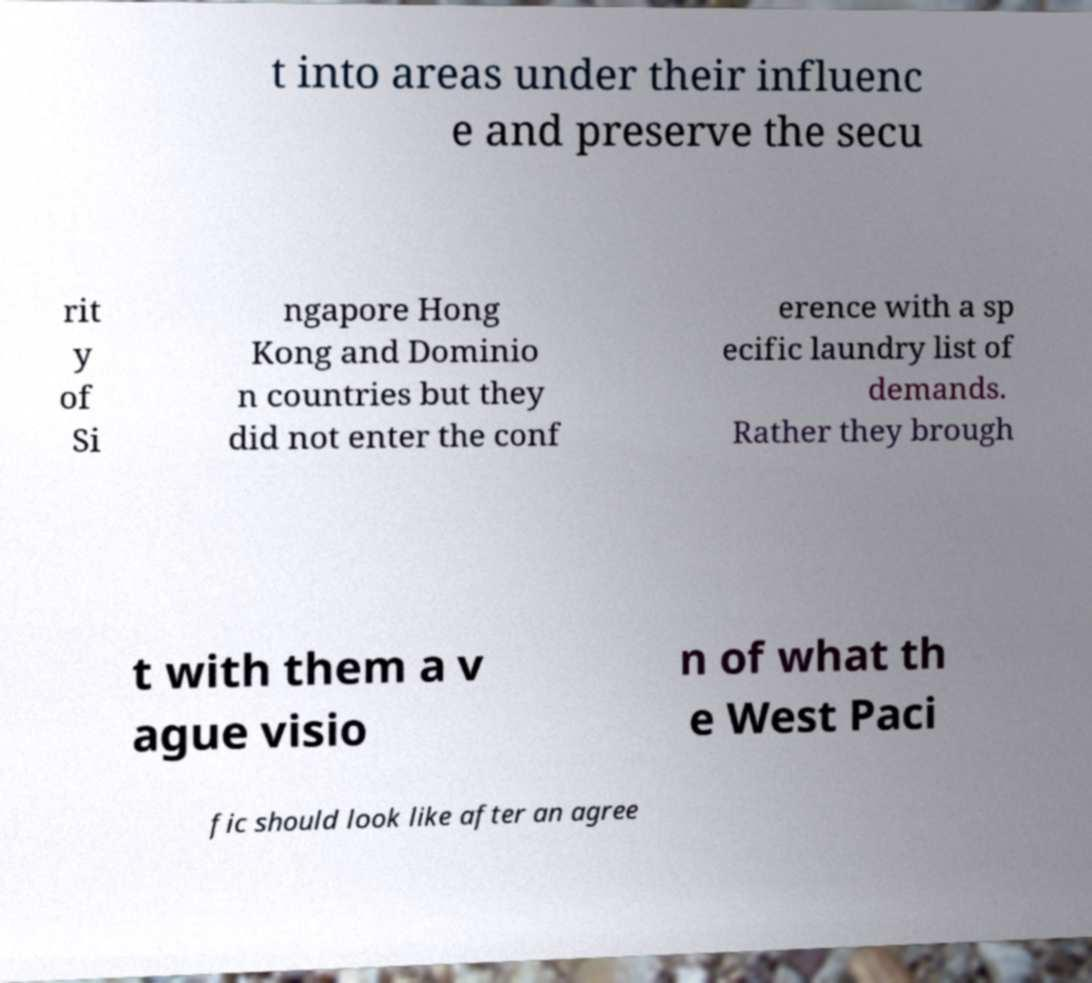Could you assist in decoding the text presented in this image and type it out clearly? t into areas under their influenc e and preserve the secu rit y of Si ngapore Hong Kong and Dominio n countries but they did not enter the conf erence with a sp ecific laundry list of demands. Rather they brough t with them a v ague visio n of what th e West Paci fic should look like after an agree 